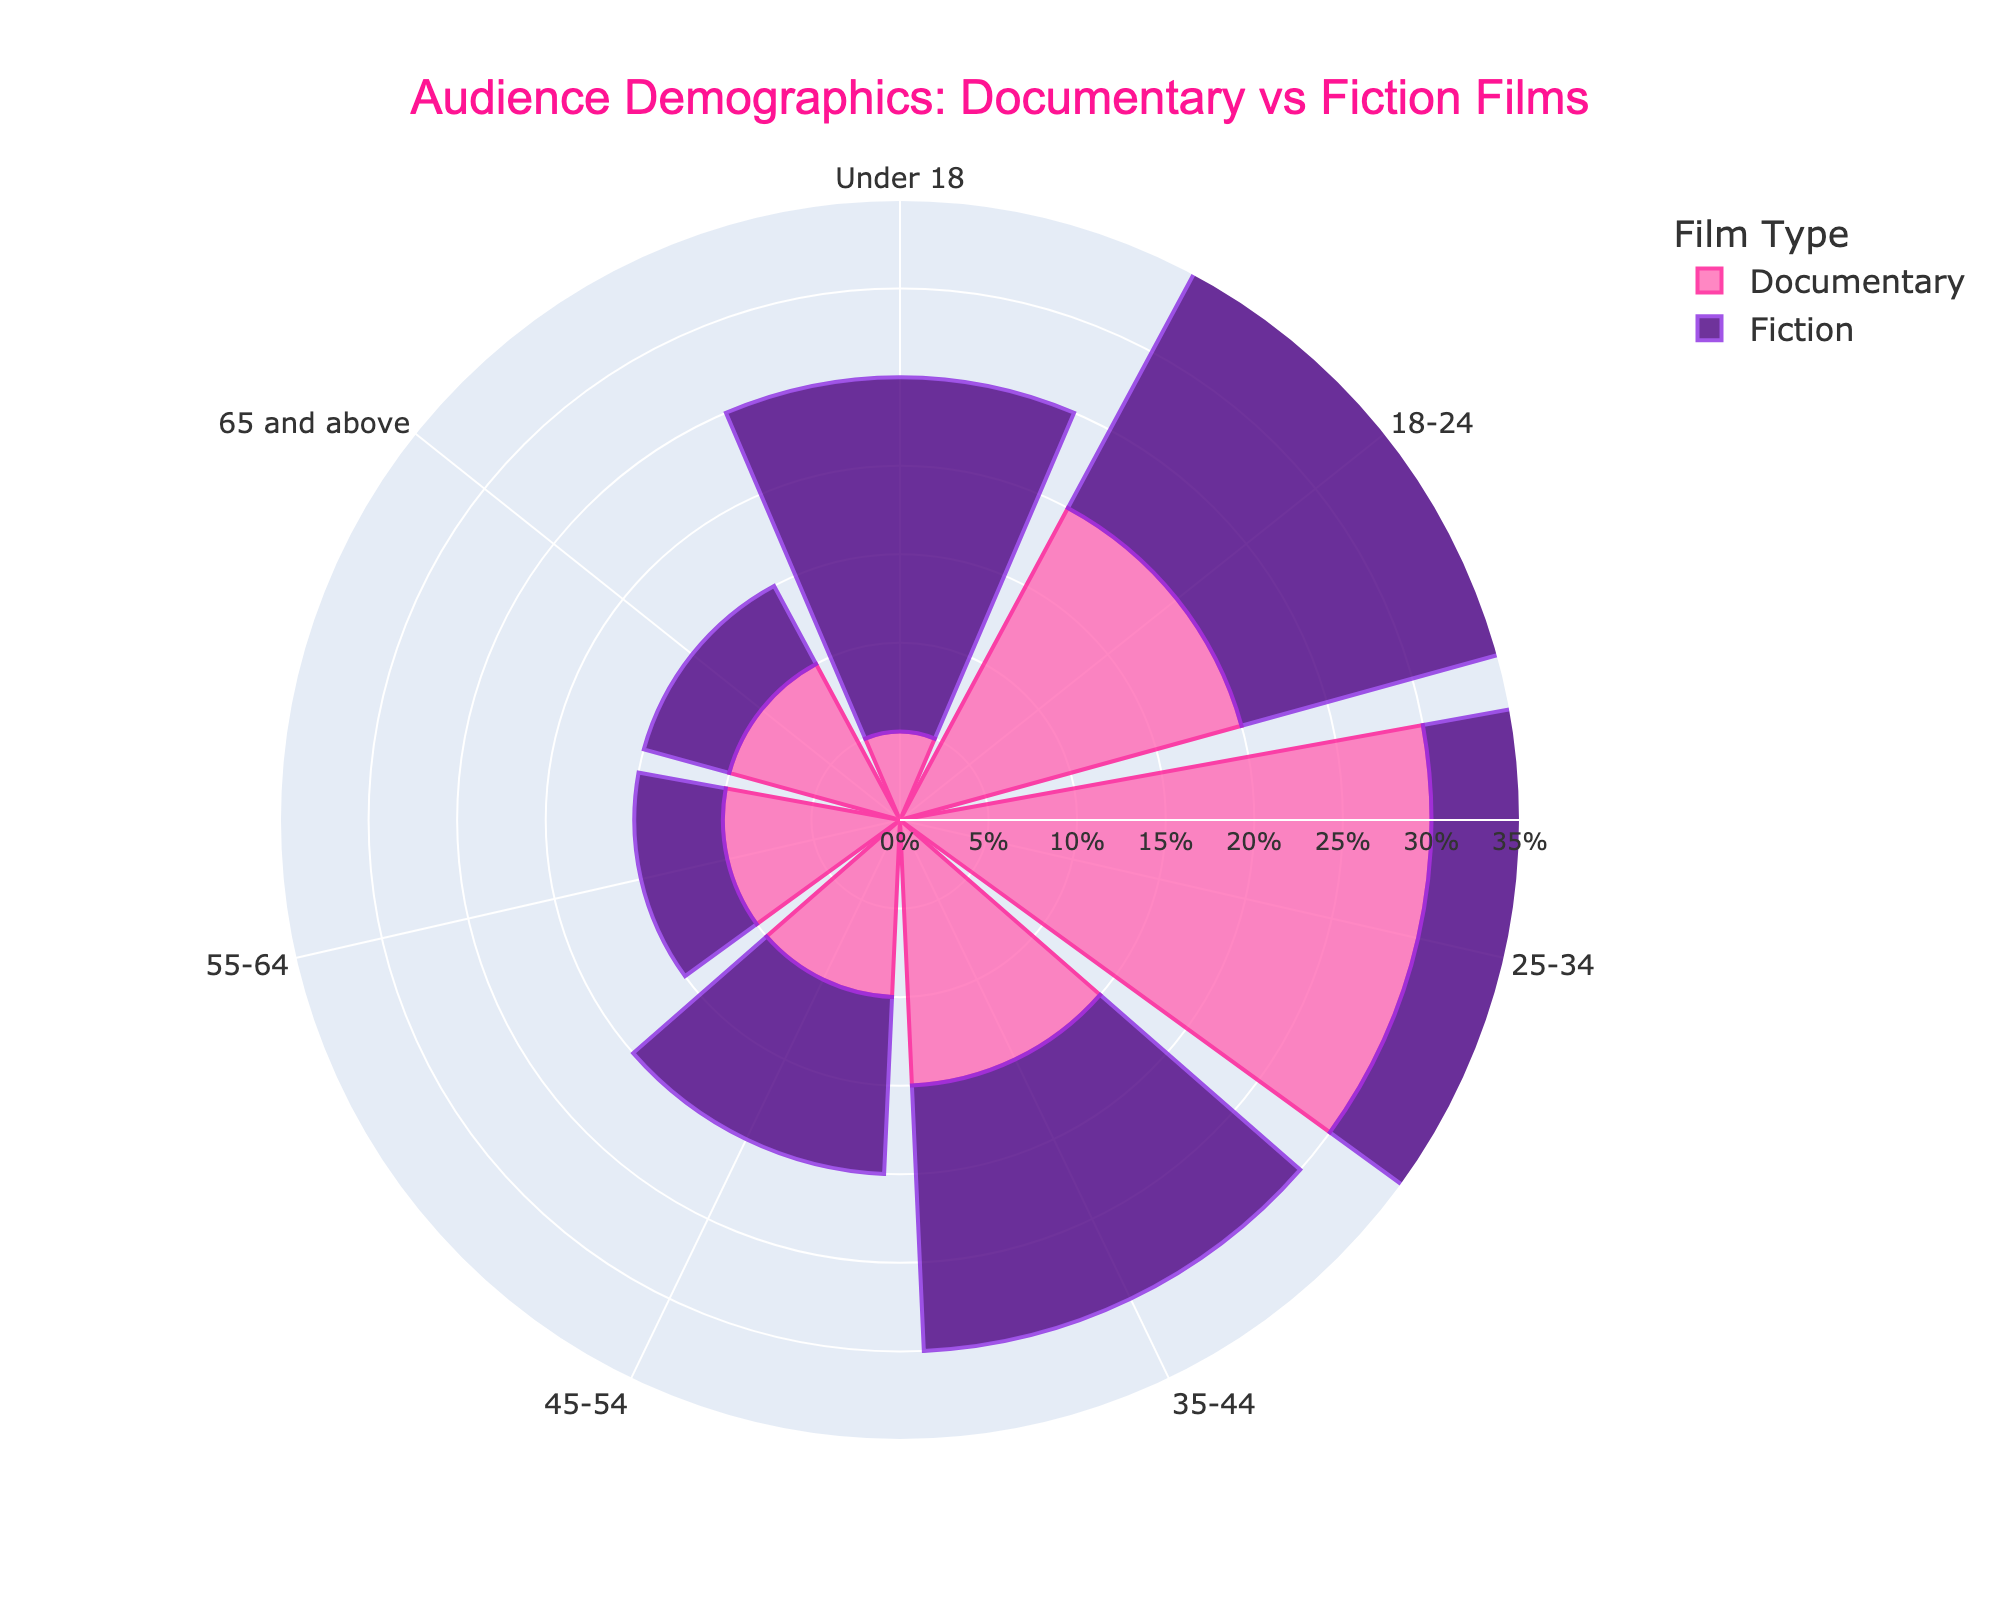What is the title of the figure? The title of the figure is situated at the top and provides a clear indication of the subject analyzed in the chart.
Answer: Audience Demographics: Documentary vs Fiction Films Which Age Group has the highest percentage representation for Documentary Films? Look at the pink segments of the rose chart corresponding to Documentary Films and identify which age group segment extends the furthest from the center. This indicates the highest representation.
Answer: 25-34 Which Age Group has the lowest percentage representation for Fiction Films? Identify the purple segments related to Fiction Films and see which age group segment is the shortest.
Answer: 55-64 and 65 and above What is the percentage difference for the 18-24 Age Group between Documentary and Fiction Films? Subtract the Documentary percentage for the 18-24 Age Group from the Fiction percentage for the same group (25% - 20%).
Answer: 5% How does the representation of the 55-64 Age Group compare between Documentary and Fiction Films? Note the lengths of the pink and purple segments at the 55-64 Age Group position and compare them directly.
Answer: Documentary has a higher representation What age group has the same percentage representation in both Documentary and Fiction Films? Scan through the Age Groups and check for segments that extend the same distance for both colors.
Answer: 35-44 and 45-54 Which Film Type has a higher total percentage representation for audiences under 25? Sum the percentages of the Under 18 and 18-24 Age Groups for both Documentary and Fiction Films and compare the totals (Documentary: 5% + 20% = 25%, Fiction: 20% + 25% = 45%).
Answer: Fiction What is the average percentage representation across all age groups for Documentary Films? Add the percentage values for all age groups in Documentary Films and divide by the number of age groups (5 + 20 + 30 + 15 + 10 + 10 + 10 = 100, 100/7 ≈ 14.29%).
Answer: ≈ 14.29% By how much does the representation of the 25-34 Age Group differ between Documentary and Fiction Films? Subtract the Documentary percentage from the Fiction percentage for the 25-34 Age Group (30% - 20%).
Answer: 10% Describe the trend of percentage representation in Fiction Films as the age groups progress from younger to older. Observing the Fiction Film segments, initially, the percentages higher at younger ages and decrease progressively as the age groups increase. The trend is a decreasing representation with increasing age.
Answer: Decreasing trend with increasing age 